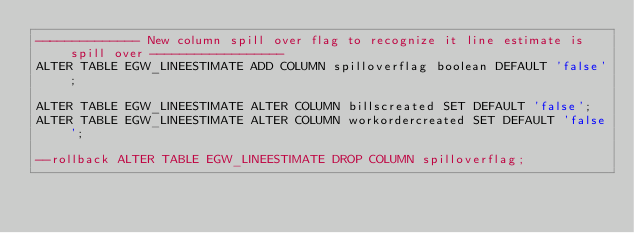Convert code to text. <code><loc_0><loc_0><loc_500><loc_500><_SQL_>-------------- New column spill over flag to recognize it line estimate is spill over ------------------
ALTER TABLE EGW_LINEESTIMATE ADD COLUMN spilloverflag boolean DEFAULT 'false';

ALTER TABLE EGW_LINEESTIMATE ALTER COLUMN billscreated SET DEFAULT 'false';
ALTER TABLE EGW_LINEESTIMATE ALTER COLUMN workordercreated SET DEFAULT 'false';

--rollback ALTER TABLE EGW_LINEESTIMATE DROP COLUMN spilloverflag;</code> 